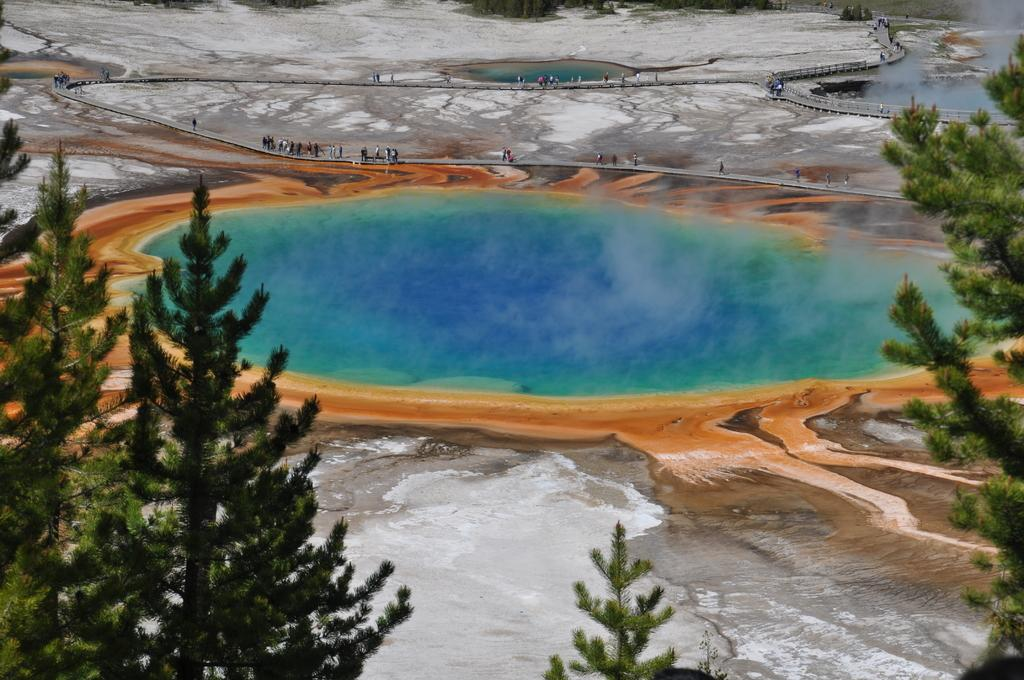What type of body of water is in the image? There is a lake in the image. What colors can be seen in the water of the lake? The water in the lake has blue and green colors. What is coming out of the lake? Smoke is coming out of the lake. What surrounds the lake? The lake is surrounded by sand. What type of vegetation is present around the lake? Trees are present around the lake. What other geological features are near the lake? Rocks are located near the lake. Can you see a potato growing in the lake in the image? There is no potato growing in the lake in the image. Is anyone skating on the lake in the image? There is no one skating on the lake in the image. 